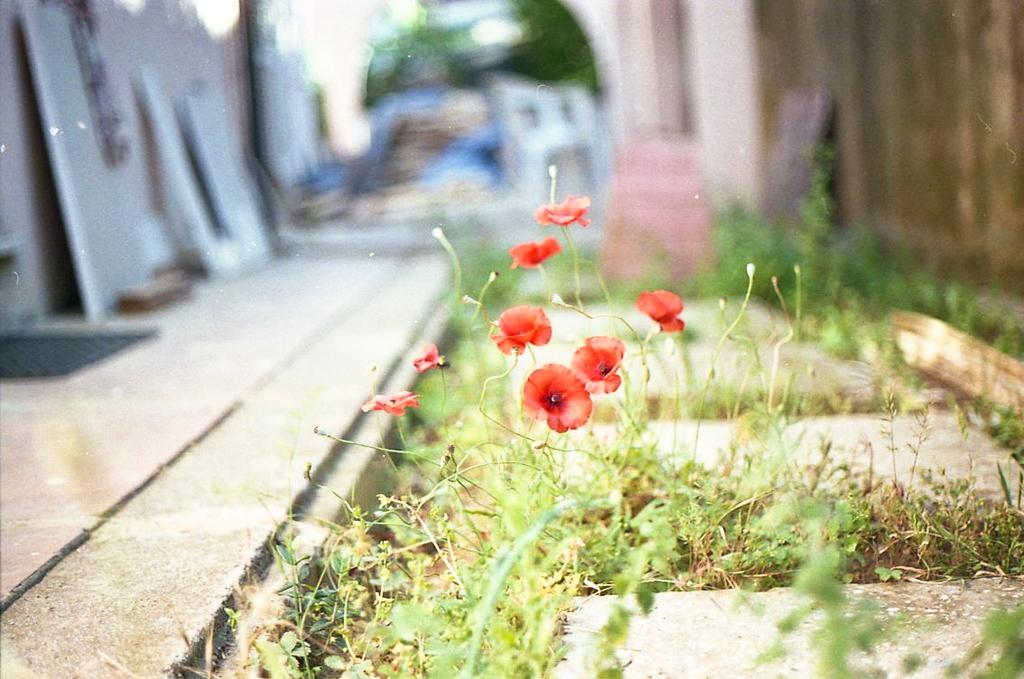What can be seen in the image that people might walk on? There is a path in the image that people might walk on. What type of vegetation is present in the image? There are plants in the image, including red flowers. How is the background of the image depicted? The background of the image is blurred. How many zebras can be seen grazing on the plants in the image? There are no zebras present in the image; it features a path, plants, and red flowers. What type of animal is sitting on the doll in the image? There is no doll or animal present in the image. 